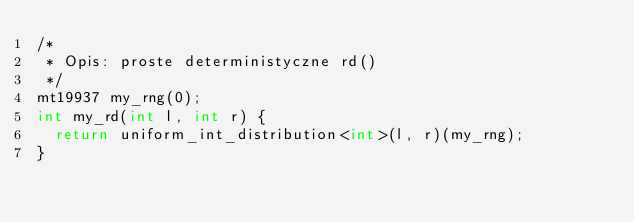<code> <loc_0><loc_0><loc_500><loc_500><_C++_>/*
 * Opis: proste deterministyczne rd()
 */
mt19937 my_rng(0);
int my_rd(int l, int r) {
	return uniform_int_distribution<int>(l, r)(my_rng);
}
</code> 